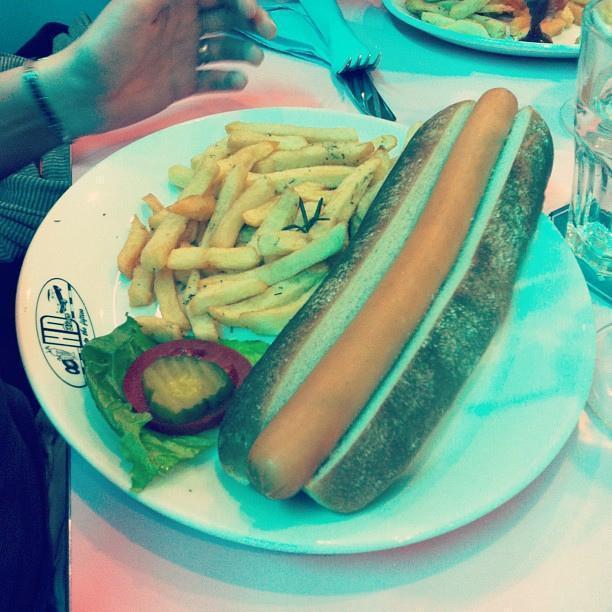Why might this longest food be unappealing to some?
Make your selection from the four choices given to correctly answer the question.
Options: Lacks condiments, uncooked, too hot, to spicy. Lacks condiments. 